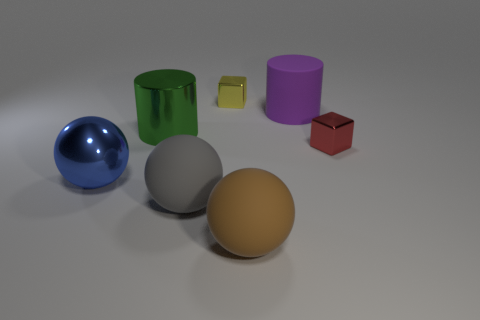Is the small red thing the same shape as the yellow shiny thing?
Keep it short and to the point. Yes. How many things are either gray things or metal things that are left of the large brown rubber object?
Your response must be concise. 4. How many small shiny cylinders are there?
Your answer should be very brief. 0. Is there a blue shiny thing that has the same size as the brown rubber sphere?
Your answer should be compact. Yes. Are there fewer gray matte balls that are on the left side of the large blue sphere than green cubes?
Ensure brevity in your answer.  No. Does the metallic cylinder have the same size as the yellow shiny cube?
Offer a very short reply. No. There is a brown ball that is made of the same material as the large purple cylinder; what is its size?
Give a very brief answer. Large. What number of large shiny cylinders have the same color as the rubber cylinder?
Give a very brief answer. 0. Are there fewer rubber things left of the big purple matte cylinder than big objects that are in front of the green shiny object?
Ensure brevity in your answer.  Yes. Do the big rubber thing that is behind the large green thing and the green shiny thing have the same shape?
Give a very brief answer. Yes. 